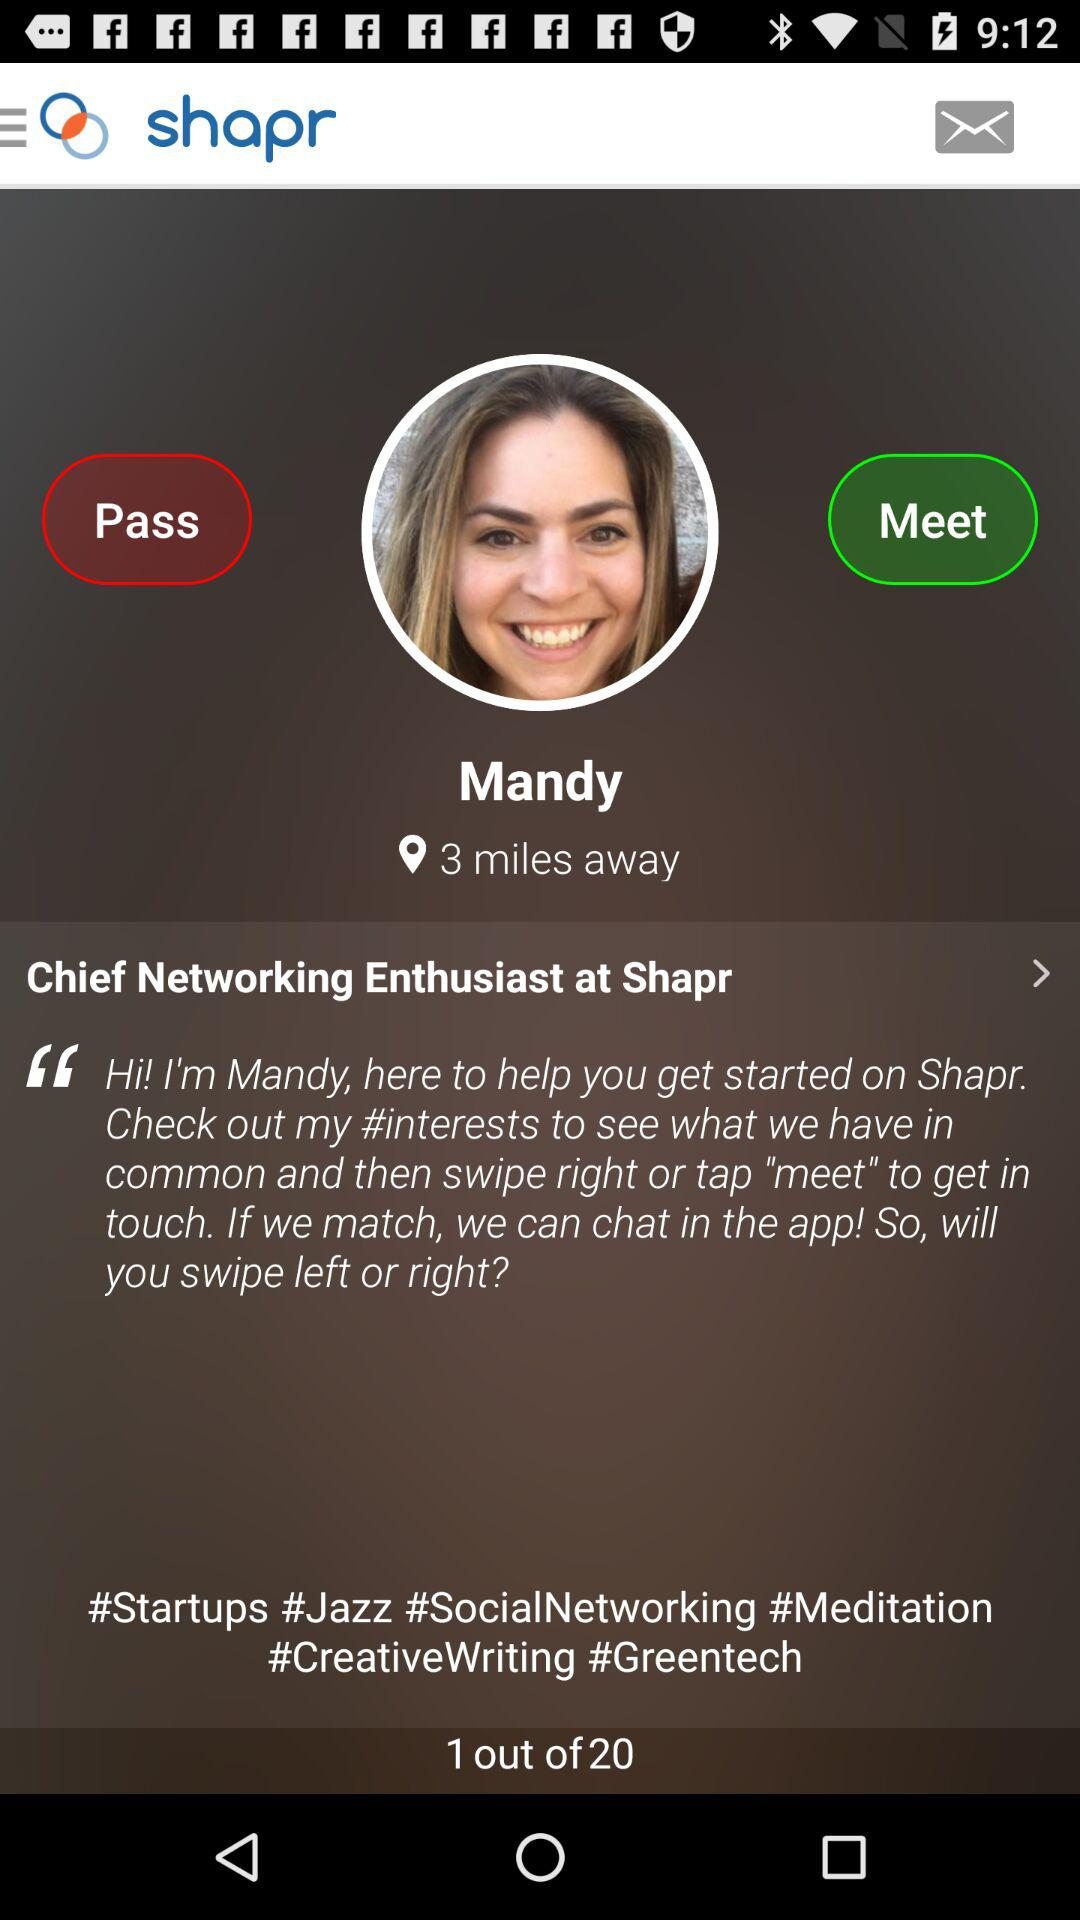What is the mentioned distance? The mentioned distance is 3 miles. 